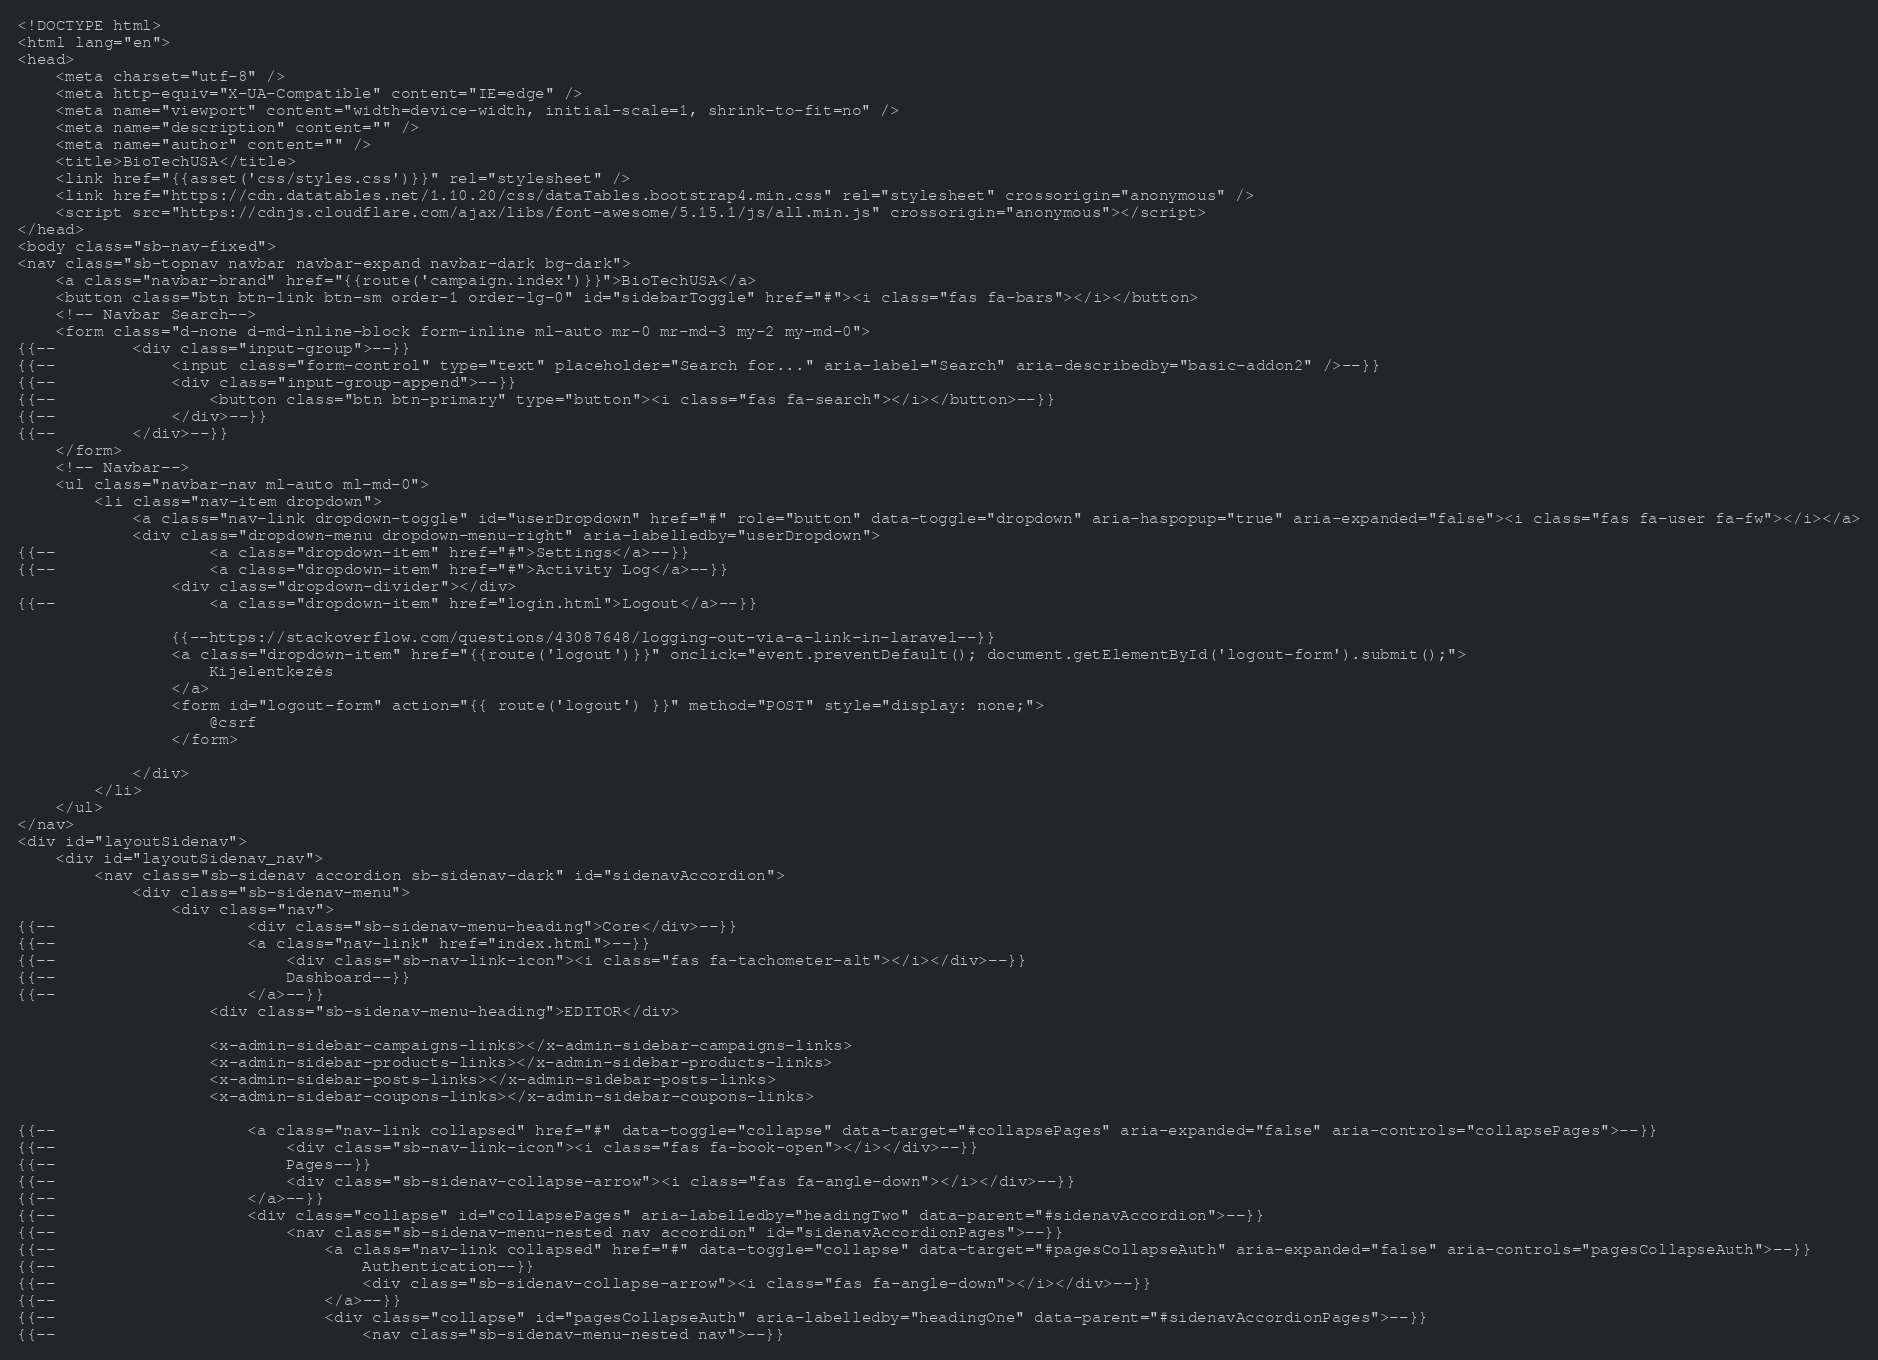Convert code to text. <code><loc_0><loc_0><loc_500><loc_500><_PHP_><!DOCTYPE html>
<html lang="en">
<head>
    <meta charset="utf-8" />
    <meta http-equiv="X-UA-Compatible" content="IE=edge" />
    <meta name="viewport" content="width=device-width, initial-scale=1, shrink-to-fit=no" />
    <meta name="description" content="" />
    <meta name="author" content="" />
    <title>BioTechUSA</title>
    <link href="{{asset('css/styles.css')}}" rel="stylesheet" />
    <link href="https://cdn.datatables.net/1.10.20/css/dataTables.bootstrap4.min.css" rel="stylesheet" crossorigin="anonymous" />
    <script src="https://cdnjs.cloudflare.com/ajax/libs/font-awesome/5.15.1/js/all.min.js" crossorigin="anonymous"></script>
</head>
<body class="sb-nav-fixed">
<nav class="sb-topnav navbar navbar-expand navbar-dark bg-dark">
    <a class="navbar-brand" href="{{route('campaign.index')}}">BioTechUSA</a>
    <button class="btn btn-link btn-sm order-1 order-lg-0" id="sidebarToggle" href="#"><i class="fas fa-bars"></i></button>
    <!-- Navbar Search-->
    <form class="d-none d-md-inline-block form-inline ml-auto mr-0 mr-md-3 my-2 my-md-0">
{{--        <div class="input-group">--}}
{{--            <input class="form-control" type="text" placeholder="Search for..." aria-label="Search" aria-describedby="basic-addon2" />--}}
{{--            <div class="input-group-append">--}}
{{--                <button class="btn btn-primary" type="button"><i class="fas fa-search"></i></button>--}}
{{--            </div>--}}
{{--        </div>--}}
    </form>
    <!-- Navbar-->
    <ul class="navbar-nav ml-auto ml-md-0">
        <li class="nav-item dropdown">
            <a class="nav-link dropdown-toggle" id="userDropdown" href="#" role="button" data-toggle="dropdown" aria-haspopup="true" aria-expanded="false"><i class="fas fa-user fa-fw"></i></a>
            <div class="dropdown-menu dropdown-menu-right" aria-labelledby="userDropdown">
{{--                <a class="dropdown-item" href="#">Settings</a>--}}
{{--                <a class="dropdown-item" href="#">Activity Log</a>--}}
                <div class="dropdown-divider"></div>
{{--                <a class="dropdown-item" href="login.html">Logout</a>--}}

                {{--https://stackoverflow.com/questions/43087648/logging-out-via-a-link-in-laravel--}}
                <a class="dropdown-item" href="{{route('logout')}}" onclick="event.preventDefault(); document.getElementById('logout-form').submit();">
                    Kijelentkezés
                </a>
                <form id="logout-form" action="{{ route('logout') }}" method="POST" style="display: none;">
                    @csrf
                </form>

            </div>
        </li>
    </ul>
</nav>
<div id="layoutSidenav">
    <div id="layoutSidenav_nav">
        <nav class="sb-sidenav accordion sb-sidenav-dark" id="sidenavAccordion">
            <div class="sb-sidenav-menu">
                <div class="nav">
{{--                    <div class="sb-sidenav-menu-heading">Core</div>--}}
{{--                    <a class="nav-link" href="index.html">--}}
{{--                        <div class="sb-nav-link-icon"><i class="fas fa-tachometer-alt"></i></div>--}}
{{--                        Dashboard--}}
{{--                    </a>--}}
                    <div class="sb-sidenav-menu-heading">EDITOR</div>

                    <x-admin-sidebar-campaigns-links></x-admin-sidebar-campaigns-links>
                    <x-admin-sidebar-products-links></x-admin-sidebar-products-links>
                    <x-admin-sidebar-posts-links></x-admin-sidebar-posts-links>
                    <x-admin-sidebar-coupons-links></x-admin-sidebar-coupons-links>

{{--                    <a class="nav-link collapsed" href="#" data-toggle="collapse" data-target="#collapsePages" aria-expanded="false" aria-controls="collapsePages">--}}
{{--                        <div class="sb-nav-link-icon"><i class="fas fa-book-open"></i></div>--}}
{{--                        Pages--}}
{{--                        <div class="sb-sidenav-collapse-arrow"><i class="fas fa-angle-down"></i></div>--}}
{{--                    </a>--}}
{{--                    <div class="collapse" id="collapsePages" aria-labelledby="headingTwo" data-parent="#sidenavAccordion">--}}
{{--                        <nav class="sb-sidenav-menu-nested nav accordion" id="sidenavAccordionPages">--}}
{{--                            <a class="nav-link collapsed" href="#" data-toggle="collapse" data-target="#pagesCollapseAuth" aria-expanded="false" aria-controls="pagesCollapseAuth">--}}
{{--                                Authentication--}}
{{--                                <div class="sb-sidenav-collapse-arrow"><i class="fas fa-angle-down"></i></div>--}}
{{--                            </a>--}}
{{--                            <div class="collapse" id="pagesCollapseAuth" aria-labelledby="headingOne" data-parent="#sidenavAccordionPages">--}}
{{--                                <nav class="sb-sidenav-menu-nested nav">--}}</code> 